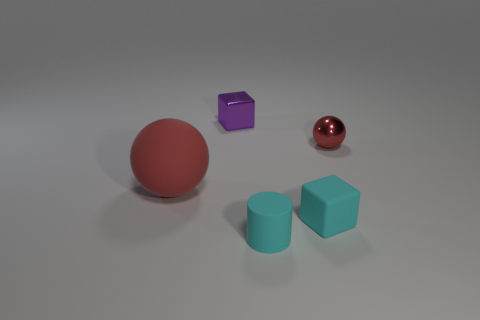Does the small red metallic object have the same shape as the large matte object? The small red metallic object, which appears to be a sphere, does indeed share its shape with the larger matte object, also a sphere, despite differences in their size, texture, and color. 